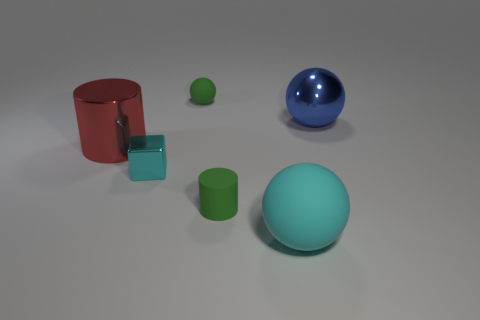There is a matte sphere that is the same size as the matte cylinder; what color is it? The matte sphere that matches the size of the matte cylinder appears to be blue in color, reflecting subtle hints of light which gives it a calming hue. 